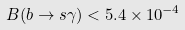<formula> <loc_0><loc_0><loc_500><loc_500>B ( b \to s \gamma ) < 5 . 4 \times 1 0 ^ { - 4 }</formula> 